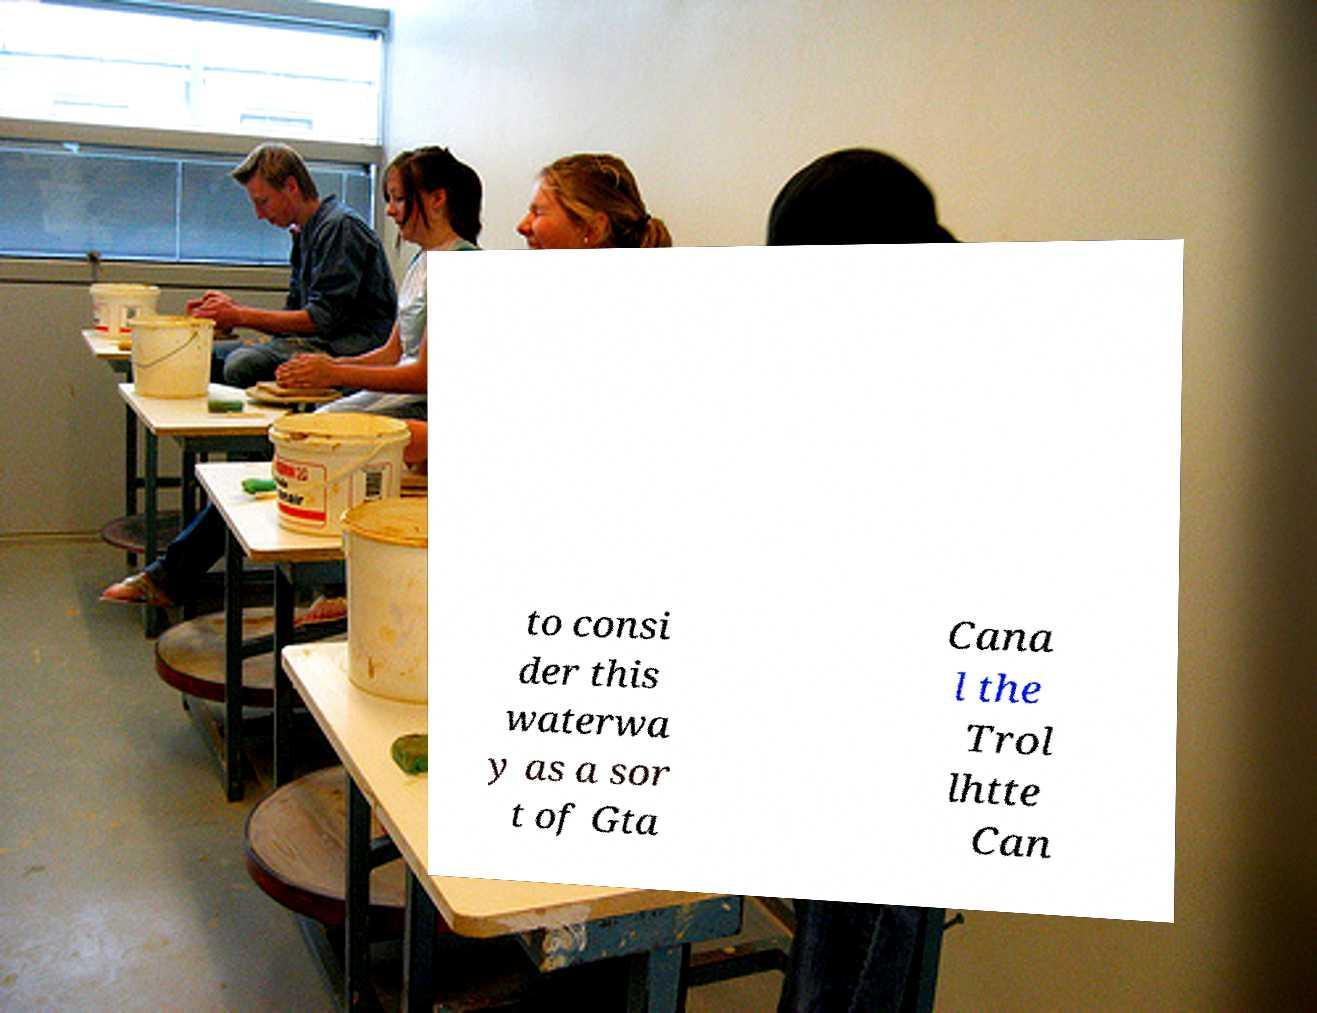Please identify and transcribe the text found in this image. to consi der this waterwa y as a sor t of Gta Cana l the Trol lhtte Can 